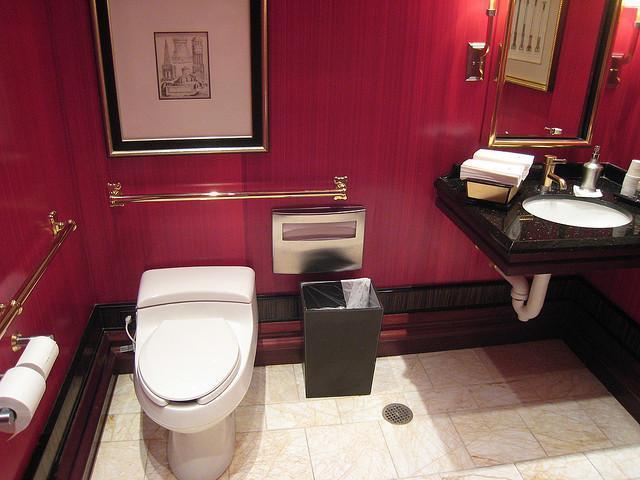How many rolls of toilet paper are visible?
Give a very brief answer. 2. 